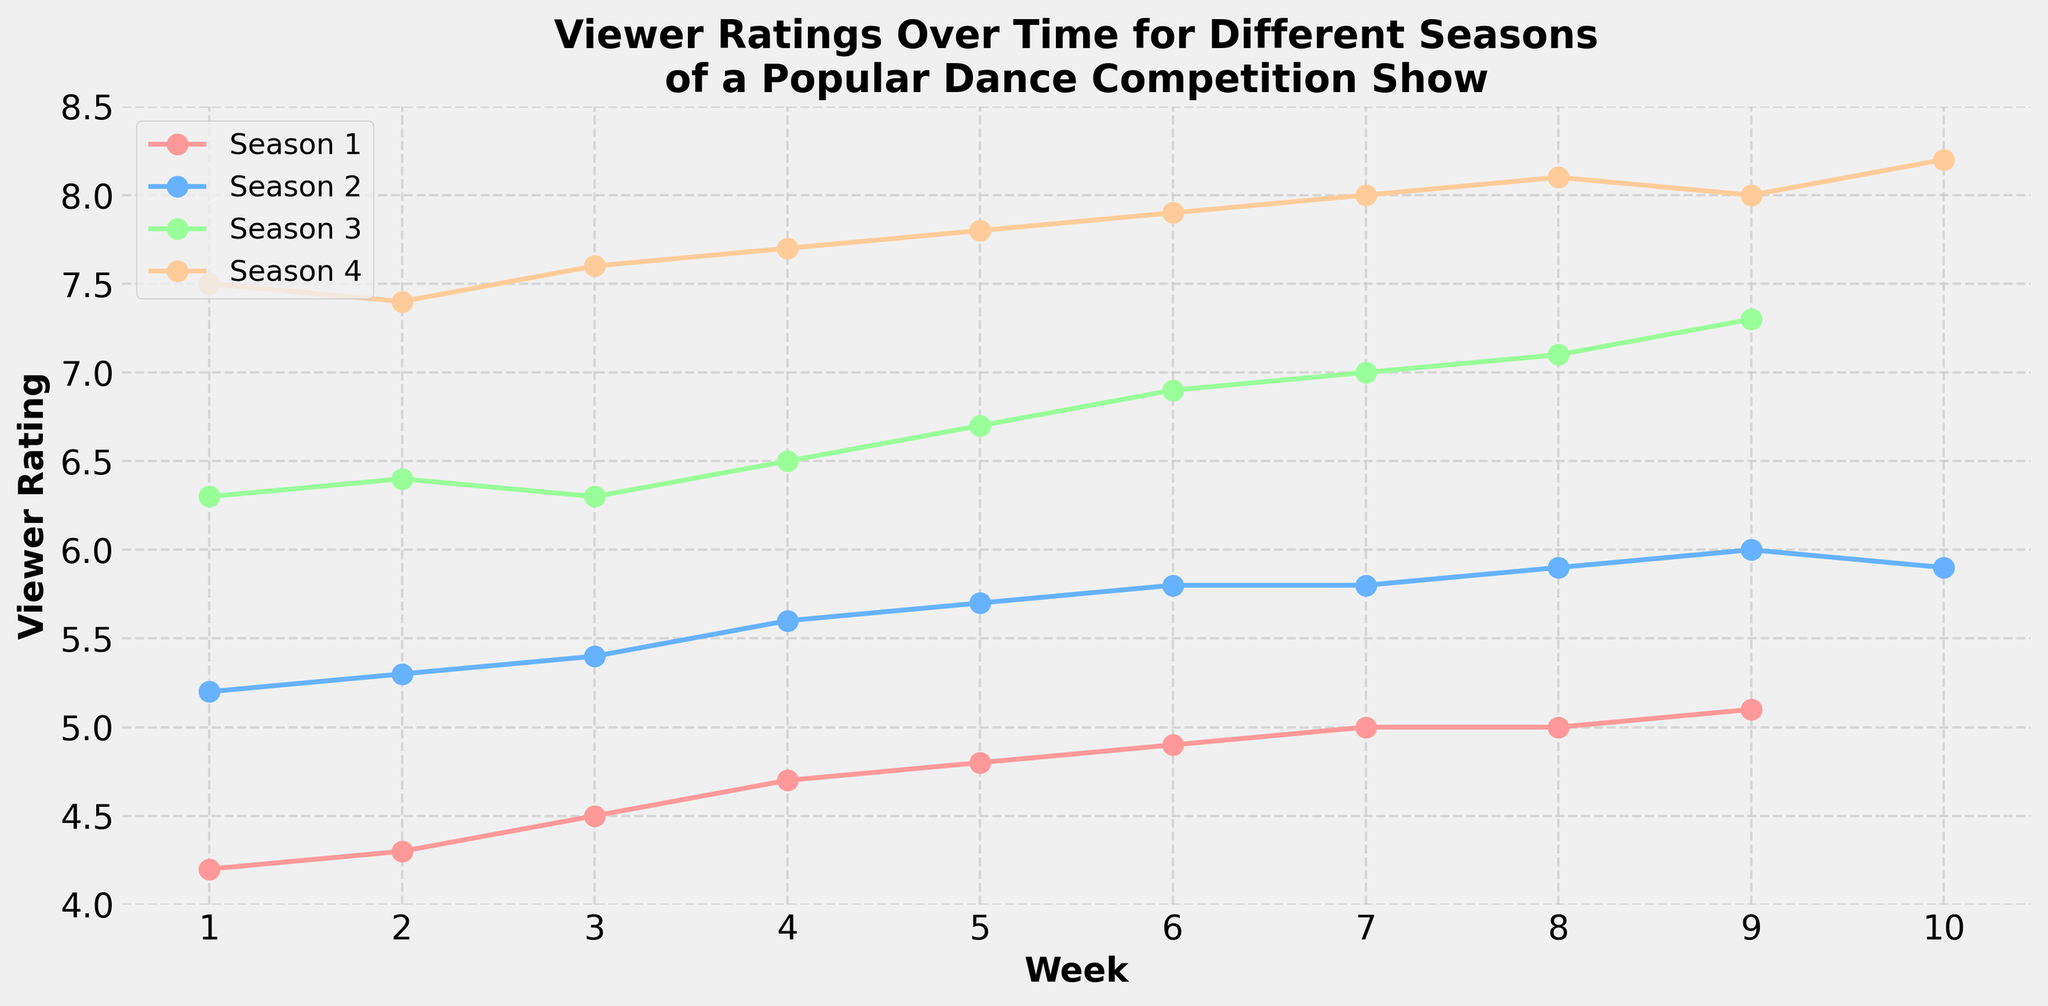What's the title of the plot? The title of a plot is typically at the top of the figure, and in this case, it is evident.
Answer: Viewer Ratings Over Time for Different Seasons of a Popular Dance Competition Show How many weeks are shown for Season 4? You can count the number of data points or markers for Season 4 on the x-axis. Season 4 has multiple markers spread across the plot.
Answer: 10 Which season had the highest viewer rating? Look at the y-axis values for the peaks of each season's line. The highest peak is for the season with the highest viewer rating.
Answer: Season 4 What is the trend in viewer ratings for Season 1? Observe the line corresponding to Season 1 from Week 1 to Week 9. The line starts at a lower value and consistently moves upward.
Answer: Increasing trend Compare the viewer ratings between Week 1 of Season 1 and Week 4 of Season 3. Identify the points for Week 1 of Season 1 and Week 4 of Season 3 on the graph and compare their y-axis values. Week 4 of Season 3 is higher.
Answer: Higher in Week 4 of Season 3 Which weeks show a decline in viewer ratings for Season 2? Look for segments in the Season 2 line where the markers dip down. The drop primarily verifies a decline.
Answer: Week 9 to Week 10 What is the average viewer rating across all seasons in Week 6? Identify the ratings for Week 6 in all seasons and calculate the average: (4.9 + 5.8 + 6.9 + 7.9) / 4.
Answer: 6.375 What viewer rating does Season 3 start with? Check the y-axis value for the Week 1 marker on Season 3's line.
Answer: 6.3 By how much did the viewer rating in Season 4 increase from Week 1 to Week 5? Subtract the viewer rating of Week 1 from Week 5 for Season 4: 7.8 - 7.5.
Answer: 0.3 Which season had the least increase in viewer ratings from start to end? Calculate the difference in viewer ratings from the first to the last week for each season and compare. The smallest difference indicates the least increase.
Answer: Season 1 